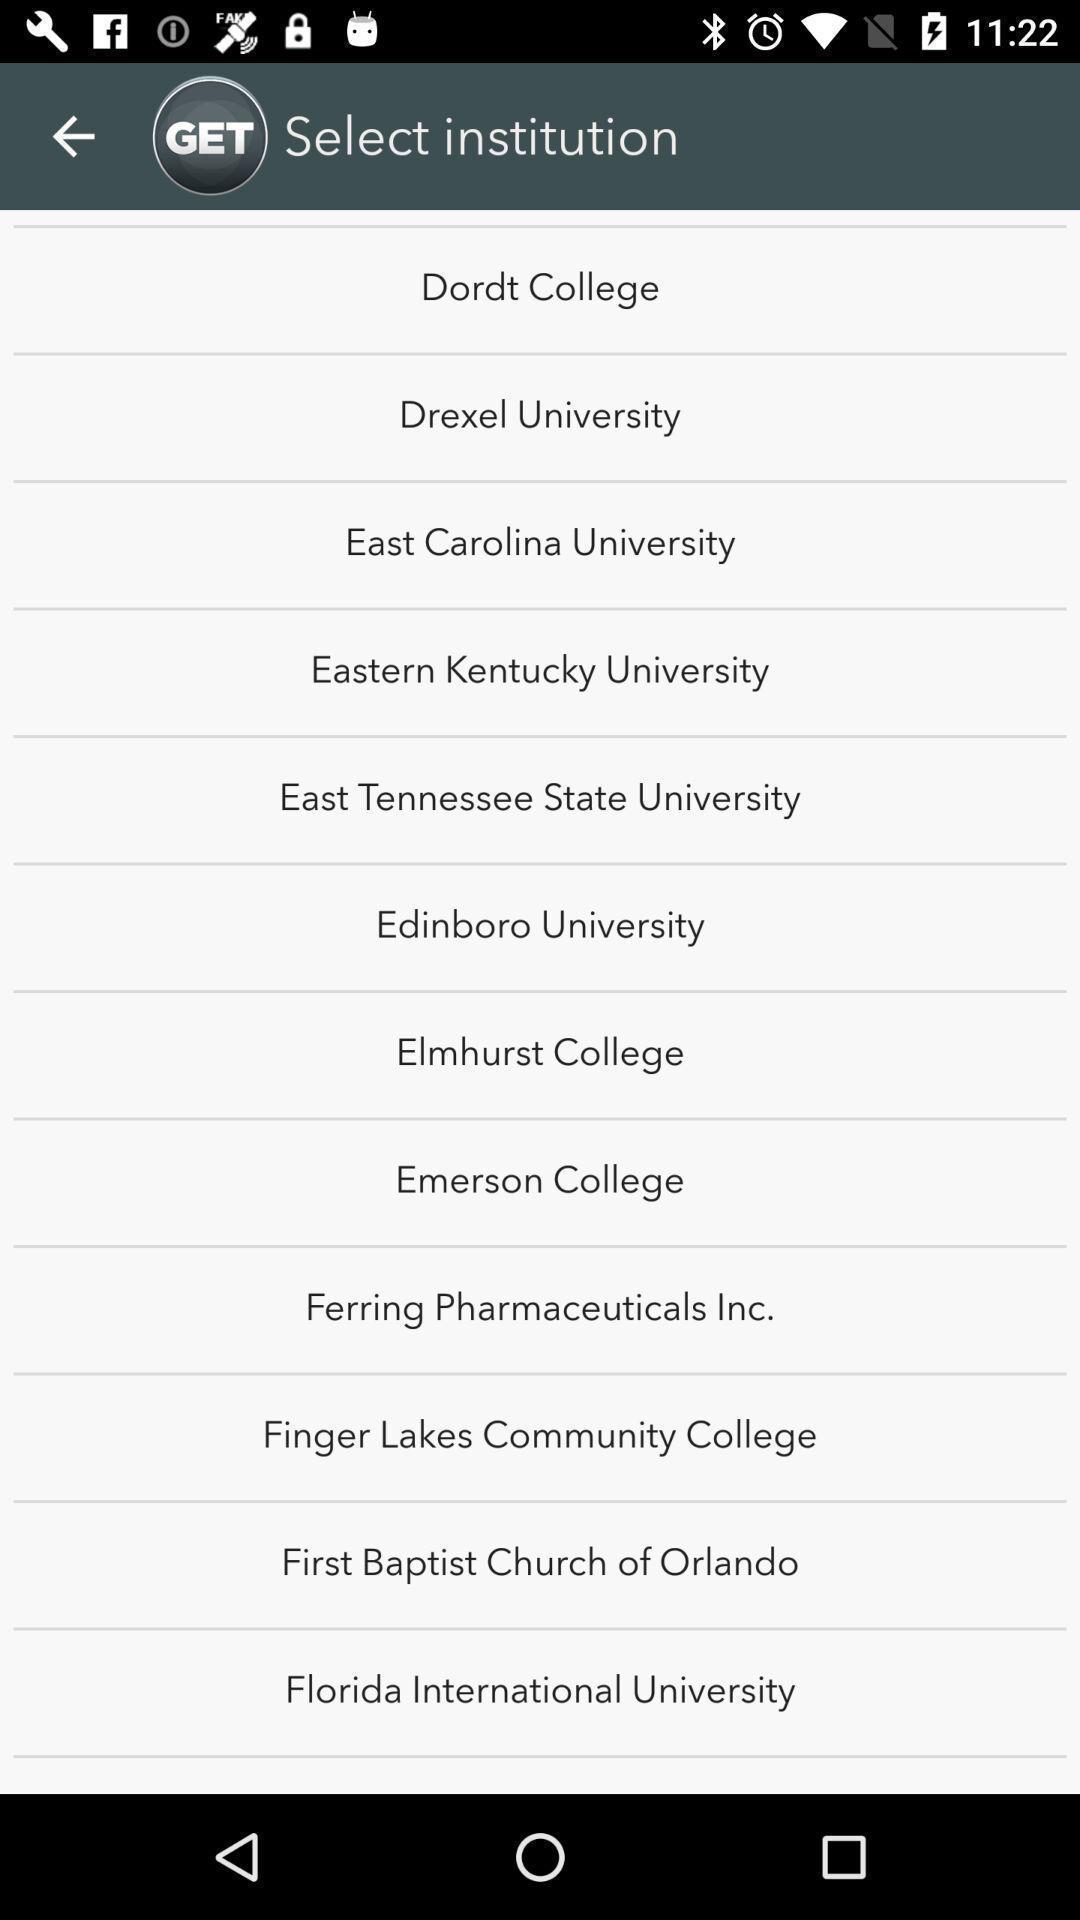Please provide a description for this image. Page showing to choose institution. 